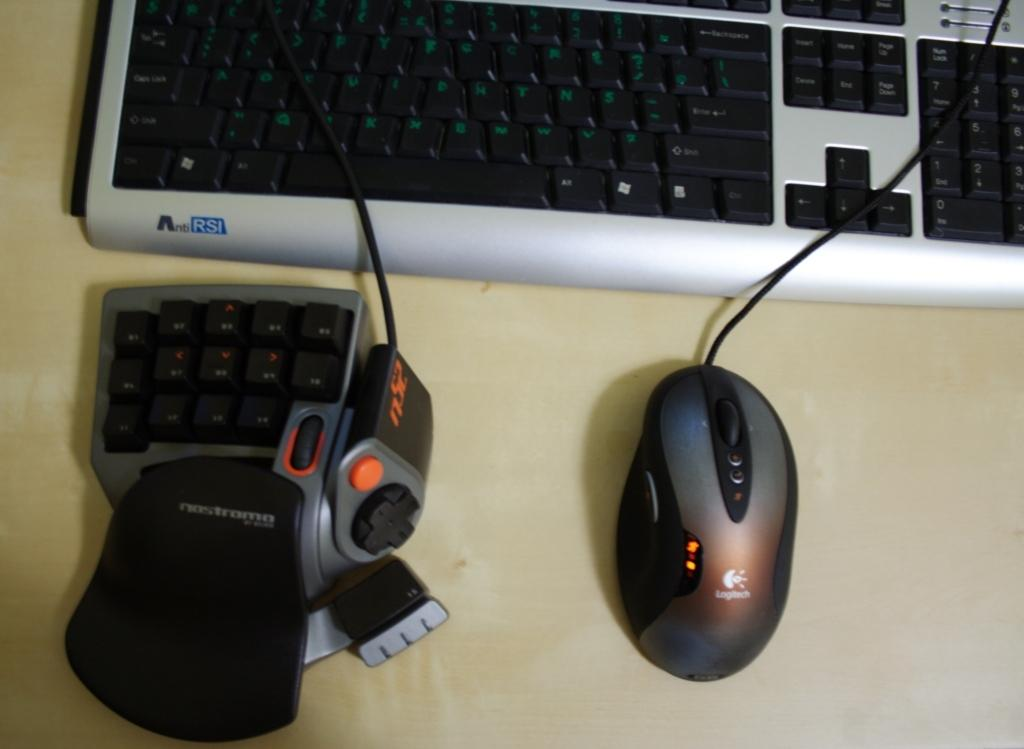What type of furniture is present in the image? There is a desk in the image. What electronic device is on the desk? There is a keyboard on the desk. What is the mouse connected to? There is a mouse with a wire on the desk. What other input device is on the image? There is a separate keypad with buttons on the desk. Is the existence of a bubble depicted in the image? No, there is no bubble present in the image. What type of drink is being consumed by the person in the image? There is no person or drink present in the image. 